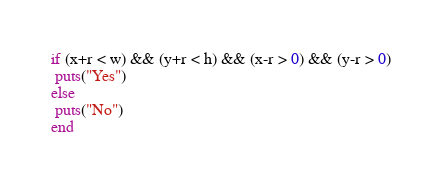Convert code to text. <code><loc_0><loc_0><loc_500><loc_500><_Ruby_>if (x+r < w) && (y+r < h) && (x-r > 0) && (y-r > 0)
 puts("Yes")
else
 puts("No")
end</code> 